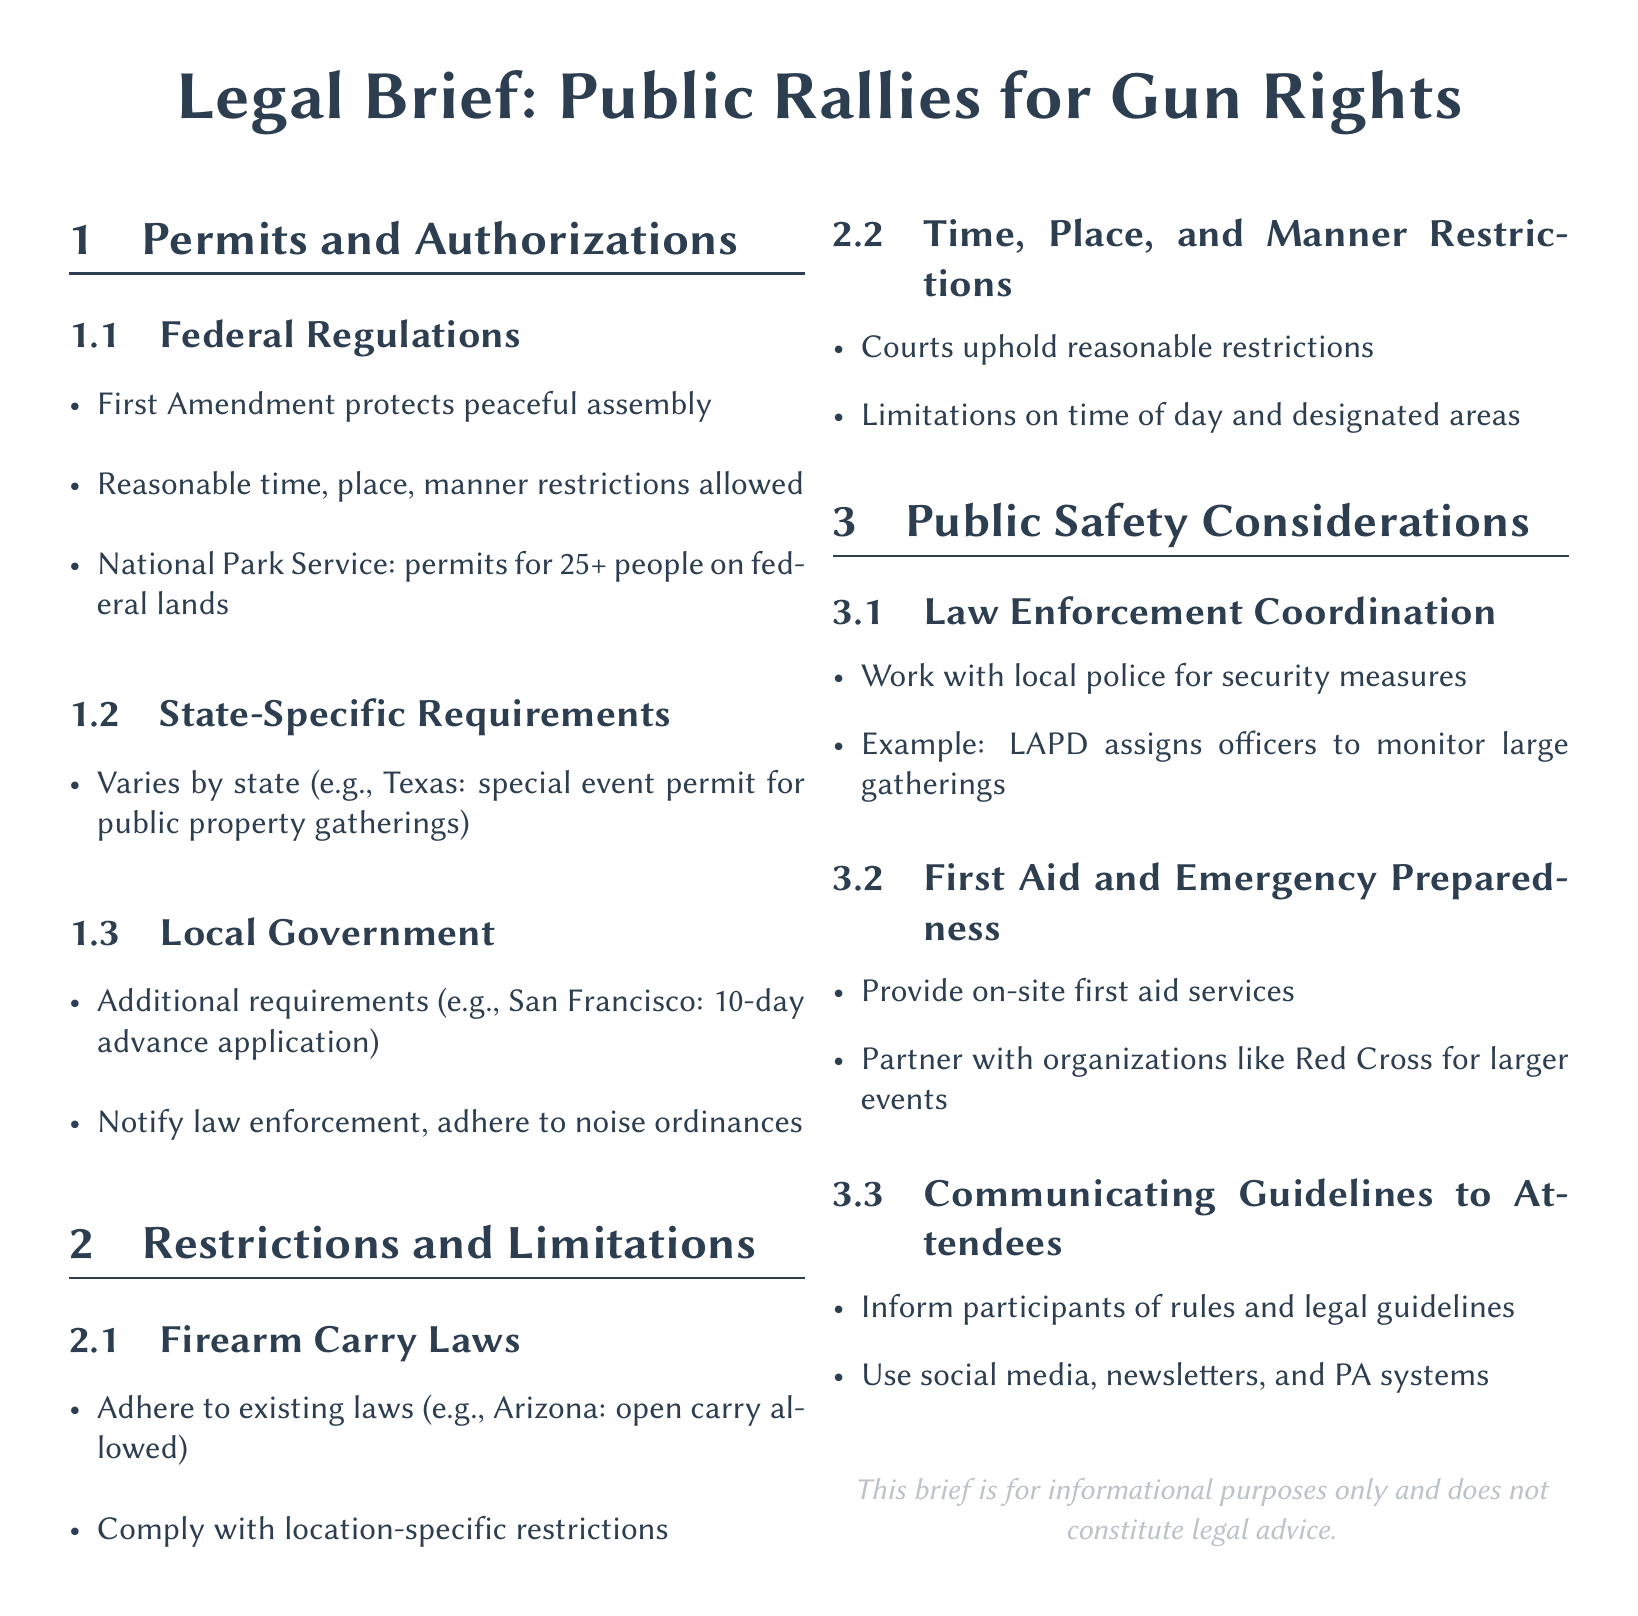What is the minimum number of people requiring a permit on federal lands? The National Park Service requires permits for gatherings of 25 or more people on federal lands.
Answer: 25 Which state's special event permit is mentioned in the document? The document mentions Texas as having a special event permit requirement for public property gatherings.
Answer: Texas What agency is suggested for coordination with local law enforcement? The document suggests that organizers should work with local police for security measures during events.
Answer: Local police What emergency service is advised to partner with for larger events? The document advises partnering with organizations like the Red Cross for providing first aid services at larger events.
Answer: Red Cross What is a common time restriction mentioned for public rallies? The courts uphold reasonable restrictions on the time of day during which events can occur, as noted in the document.
Answer: Time of day What is a specific local requirement mentioned for rally permits? San Francisco requires a 10-day advance application for rally permits.
Answer: 10-day advance application What is the primary focus of the First Amendment concerning public rallies? The First Amendment protects the right to peaceful assembly during public rallies.
Answer: Peaceful assembly What legal guideline should be communicated to attendees? Organizers should inform participants of the rules and legal guidelines for the rally.
Answer: Rules and legal guidelines 